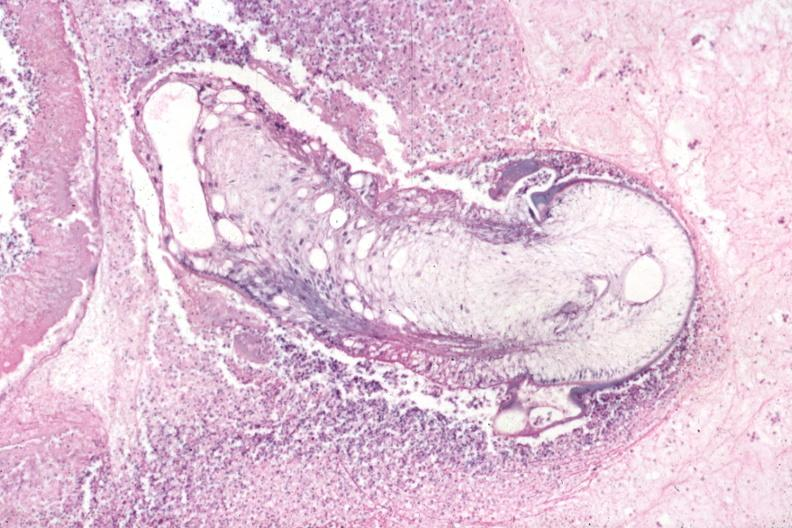s metastatic malignant melanoma present?
Answer the question using a single word or phrase. No 